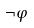Convert formula to latex. <formula><loc_0><loc_0><loc_500><loc_500>\neg \varphi</formula> 